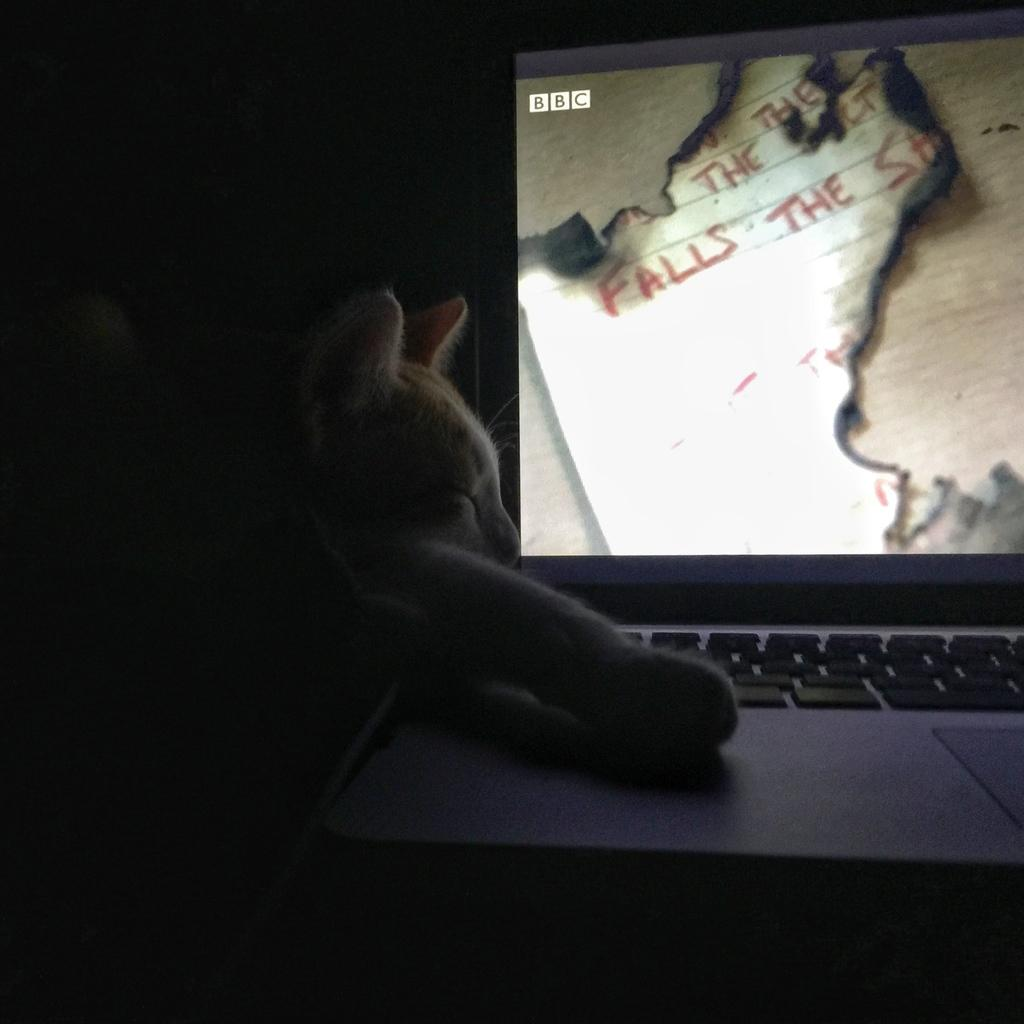What electronic device is present in the image? There is a laptop in the image. What is the current state of the laptop? The laptop is opened. What components are visible on the laptop? The laptop has a screen and keys. Is there anything unusual about the laptop in the image? Yes, a cat is visible inside the laptop. What is the cat doing in the image? The cat is sleeping. What type of property does the cat own in the image? There is no information about the cat owning any property in the image. 